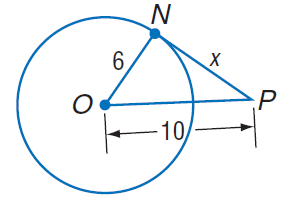Answer the mathemtical geometry problem and directly provide the correct option letter.
Question: Find x. Assume that segments that appear to be tangent are tangent.
Choices: A: 4 B: 6 C: 8 D: 19 C 